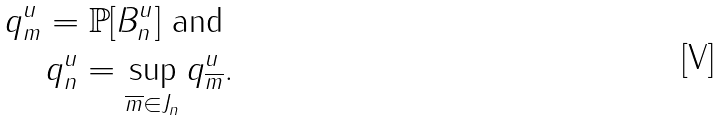<formula> <loc_0><loc_0><loc_500><loc_500>q ^ { u } _ { m } = \mathbb { P } [ B ^ { u } _ { n } ] \text { and } \\ q ^ { u } _ { n } = \sup _ { \overline { m } \in J _ { n } } q ^ { u } _ { \overline { m } } .</formula> 